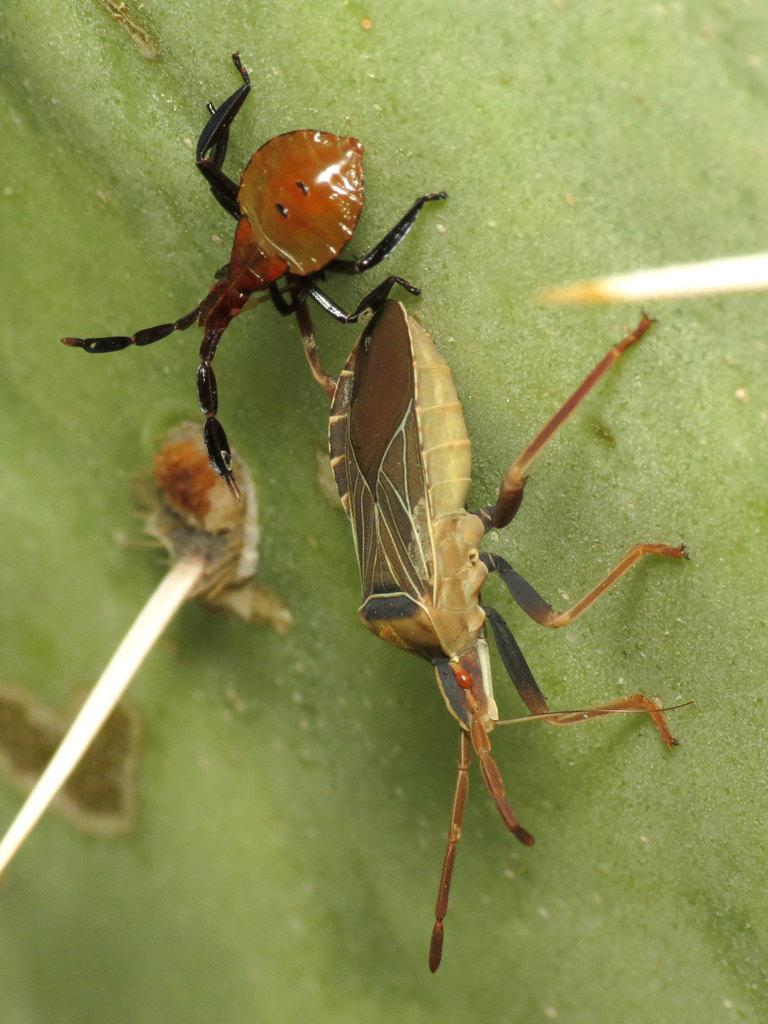What type of creatures are present in the image? There are insects in the image. Where are the insects located? The insects are on a green leaf. What type of flowers can be seen in the image? There are no flowers present in the image; it features insects on a green leaf. What type of camera was used to capture the image? The type of camera used to capture the image is not mentioned in the provided facts. 